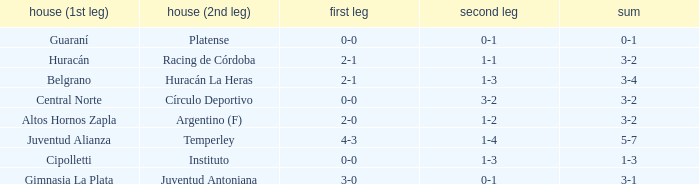What was the score of the 2nd leg when the Belgrano played the first leg at home with a score of 2-1? 1-3. 